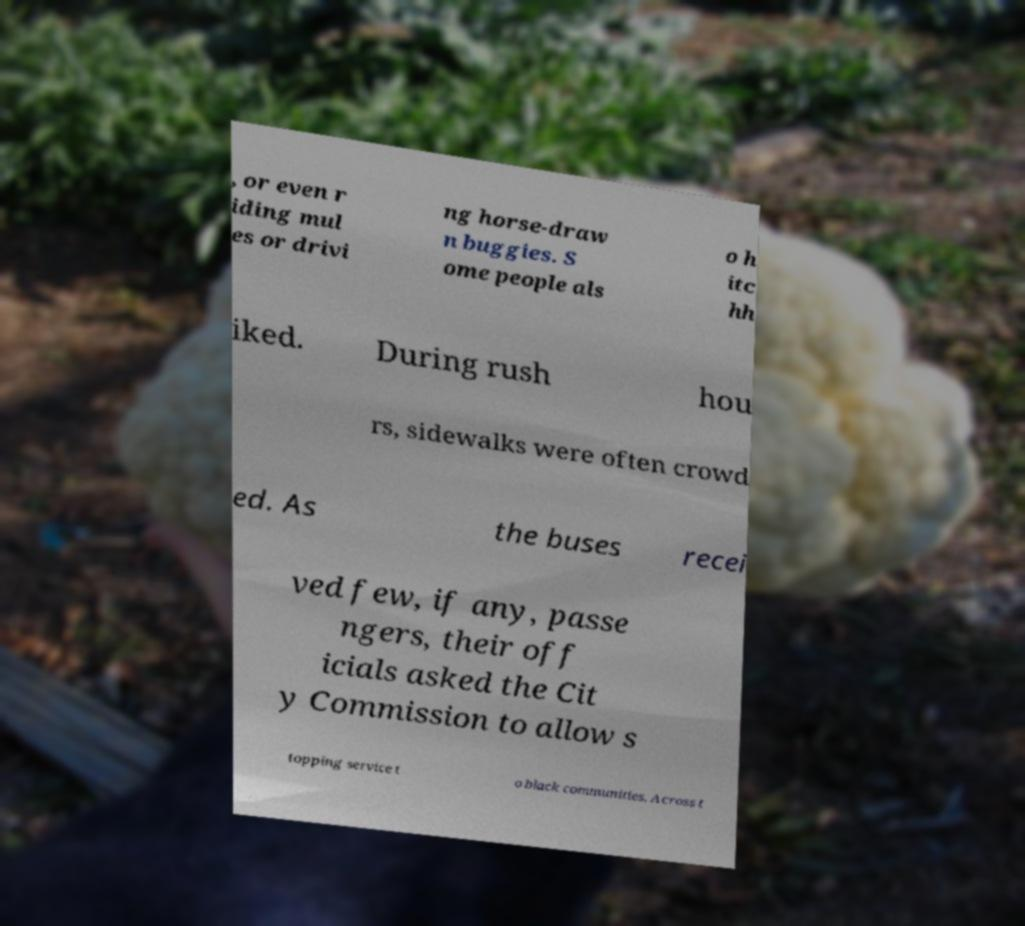Could you extract and type out the text from this image? , or even r iding mul es or drivi ng horse-draw n buggies. S ome people als o h itc hh iked. During rush hou rs, sidewalks were often crowd ed. As the buses recei ved few, if any, passe ngers, their off icials asked the Cit y Commission to allow s topping service t o black communities. Across t 